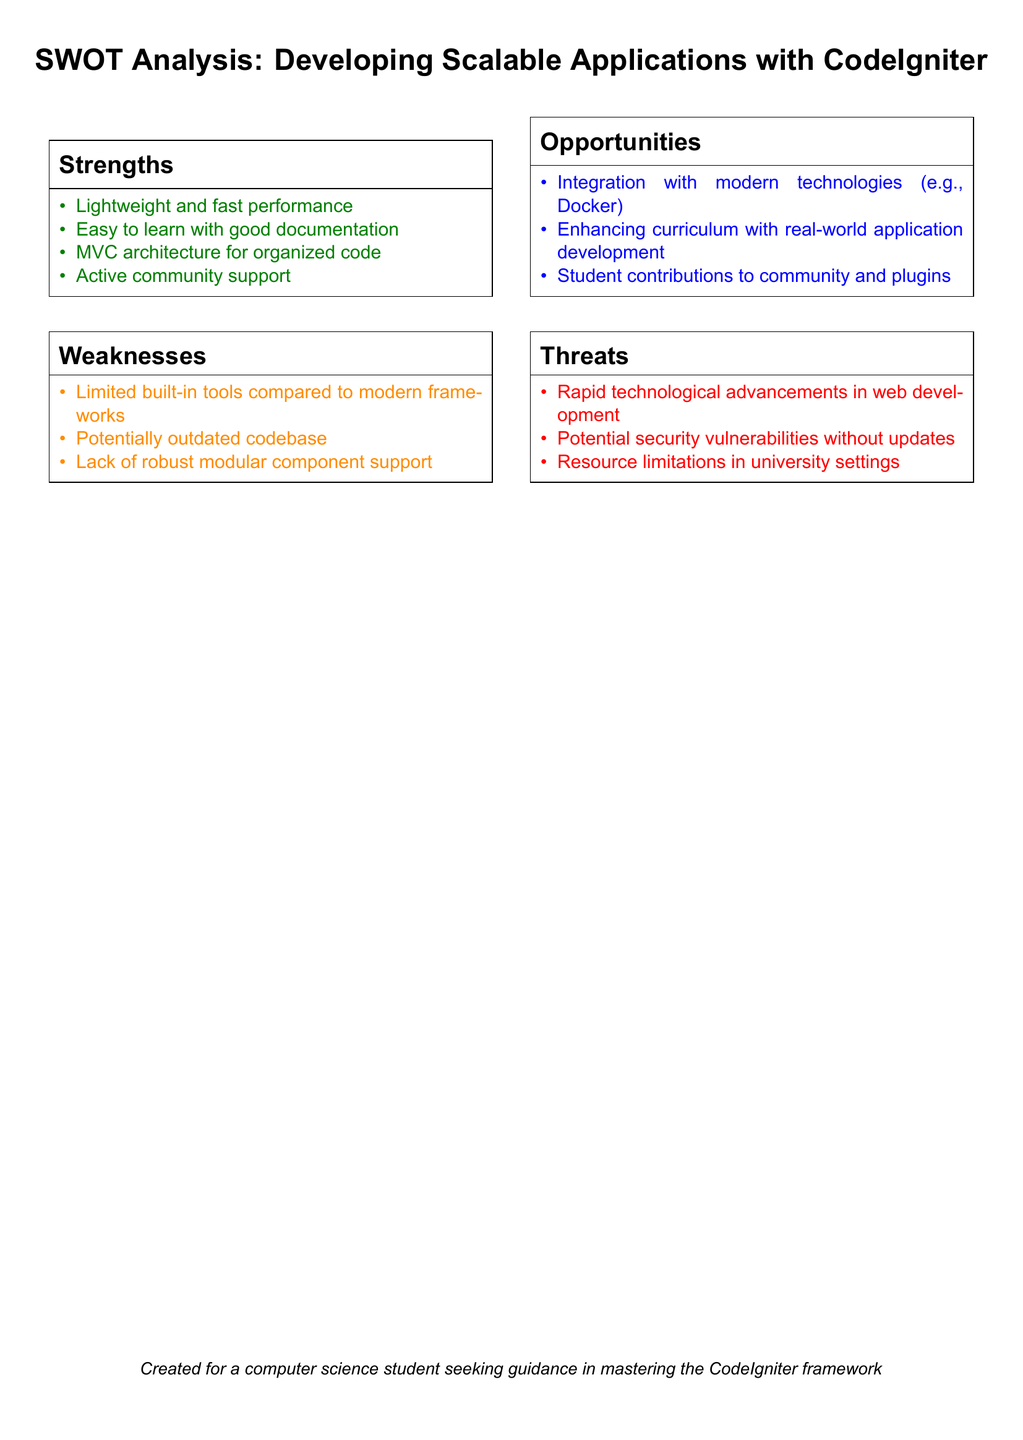What are the strengths listed in the SWOT analysis? The strengths are identified in the strengths section of the SWOT analysis, which includes lightweight performance, ease of learning, MVC architecture, and community support.
Answer: Lightweight and fast performance; Easy to learn with good documentation; MVC architecture for organized code; Active community support What weakness is associated with CodeIgniter's codebase? One of the weaknesses mentioned is that the codebase may be potentially outdated.
Answer: Potentially outdated codebase Which modern technology is mentioned as an opportunity for integration? The opportunities section mentions Docker as a technology for integration with CodeIgniter.
Answer: Docker What is one threat related to technology in the document? The threats section mentions rapid technological advancements as a potential threat in web development.
Answer: Rapid technological advancements in web development How many weaknesses are listed in the SWOT analysis? The weaknesses section includes a total of three listed points regarding CodeIgniter's limitations.
Answer: 3 What type of architectural pattern does CodeIgniter use? The strengths section specifies that CodeIgniter employs the MVC architecture for organizing code.
Answer: MVC architecture What community aspect is emphasized in the opportunities section? The opportunities section highlights student contributions to the community as a significant aspect.
Answer: Student contributions to community and plugins Which color is used to represent opportunities in the SWOT analysis? The opportunities box in the SWOT analysis uses blue as its representation color.
Answer: Blue 